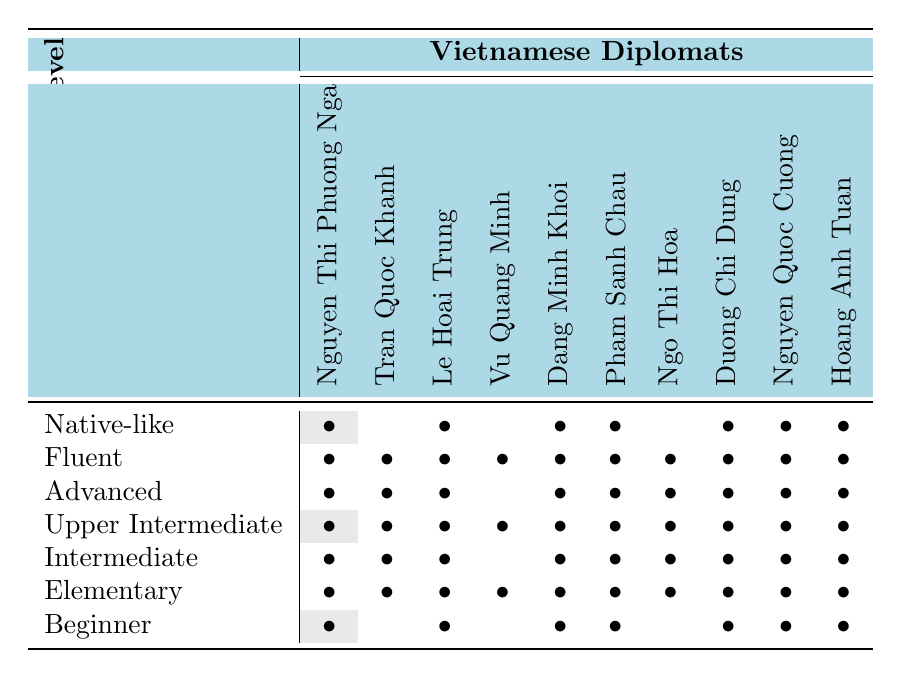What is the highest proficiency level among the diplomats? The highest proficiency level listed in the table is "Native-like." By looking at the rows, I can see where each diplomat falls under this proficiency level. I found several diplomats marked under "Native-like."
Answer: Native-like How many diplomats are at the "Fluent" level? In the table, the "Fluent" level row has all diplomats marked. Counting each symbol in that row gives me a total of 10 diplomats.
Answer: 10 Which diplomat has the lowest proficiency level? By reviewing the "Beginner" row of the table, I can count the number of marks. The lowest marks correspond to Vu Quang Minh, who is not marked in that row, which indicates they do not have a Beginner level proficiency.
Answer: Vu Quang Minh How many diplomats are at the "Upper Intermediate" level? I need to check the "Upper Intermediate" row for marks. Counting the symbols in that row reveals that all the diplomats except for one are marked under this proficiency level, resulting in 9 diplomats.
Answer: 9 Is Nguyen Thi Phuong Nga marked in the "Intermediate" level? I look at the "Intermediate" row and check if Nguyen Thi Phuong Nga has a symbol. Since there is a mark under her name in that row, then she is indeed marked under "Intermediate."
Answer: Yes What is the total number of diplomats who have an "Advanced" level? To answer, I will count the symbols in the "Advanced" row. By finding the number of diplomats marked in this row, I can determine that there are 7 diplomats with an Advanced level.
Answer: 7 Which proficiency level has the most diplomats, and how many are there? By reviewing each proficiency level's row, I compare the counts and find that all diplomats are marked under "Fluent," making it the most common proficiency level, as they all have this proficiency level.
Answer: Fluent, 10 Are any diplomats marked as "Beginner," and if so, who are they? By examining the "Beginner" level row, I can see which diplomats have a mark. Reviewing the symbols reveals that several diplomats, such as Nguyen Thi Phuong Nga, Le Hoai Trung, and others are indicated in this proficiency level.
Answer: Nguyen Thi Phuong Nga, Le Hoai Trung, Dang Minh Khoi, Pham Sanh Chau, Duong Chi Dung, Nguyen Quoc Cuong, Hoang Anh Tuan What is the proficiency level of Dang Minh Khoi? I can look at the rows and columns where Dang Minh Khoi is listed. Looking through their row, I find that Dang Minh Khoi has marks for several proficiency levels but specifically under "Advanced" and "Fluent."
Answer: Advanced, Fluent How many diplomats are either "Intermediate" or "Upper Intermediate"? For this question, I add the number of diplomats marked in both the "Intermediate" and "Upper Intermediate" rows. Counting the unique diplomats in both rows provides me the total which turns out to be 10, as they overlap.
Answer: 10 